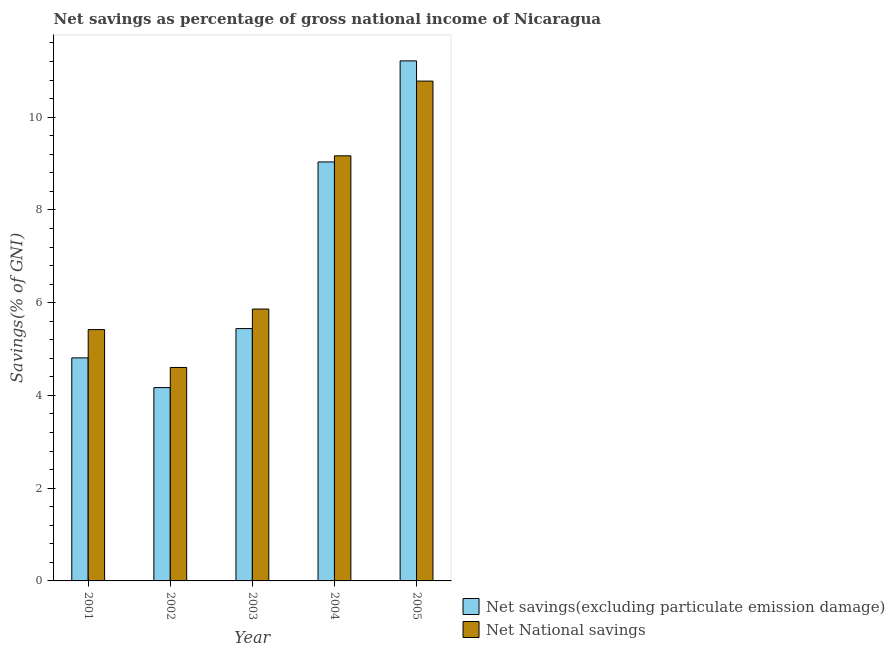Are the number of bars per tick equal to the number of legend labels?
Your answer should be very brief. Yes. Are the number of bars on each tick of the X-axis equal?
Your response must be concise. Yes. How many bars are there on the 5th tick from the right?
Your response must be concise. 2. What is the label of the 5th group of bars from the left?
Your answer should be compact. 2005. In how many cases, is the number of bars for a given year not equal to the number of legend labels?
Make the answer very short. 0. What is the net national savings in 2002?
Ensure brevity in your answer.  4.6. Across all years, what is the maximum net savings(excluding particulate emission damage)?
Provide a succinct answer. 11.21. Across all years, what is the minimum net savings(excluding particulate emission damage)?
Provide a succinct answer. 4.17. In which year was the net savings(excluding particulate emission damage) minimum?
Your response must be concise. 2002. What is the total net national savings in the graph?
Your answer should be compact. 35.83. What is the difference between the net national savings in 2001 and that in 2002?
Offer a very short reply. 0.82. What is the difference between the net national savings in 2005 and the net savings(excluding particulate emission damage) in 2004?
Keep it short and to the point. 1.61. What is the average net national savings per year?
Provide a short and direct response. 7.17. What is the ratio of the net national savings in 2001 to that in 2004?
Your answer should be compact. 0.59. Is the net savings(excluding particulate emission damage) in 2001 less than that in 2002?
Your answer should be compact. No. Is the difference between the net savings(excluding particulate emission damage) in 2002 and 2004 greater than the difference between the net national savings in 2002 and 2004?
Give a very brief answer. No. What is the difference between the highest and the second highest net savings(excluding particulate emission damage)?
Your answer should be compact. 2.18. What is the difference between the highest and the lowest net national savings?
Make the answer very short. 6.18. What does the 1st bar from the left in 2003 represents?
Your response must be concise. Net savings(excluding particulate emission damage). What does the 1st bar from the right in 2004 represents?
Your response must be concise. Net National savings. Are all the bars in the graph horizontal?
Give a very brief answer. No. How many years are there in the graph?
Offer a very short reply. 5. What is the difference between two consecutive major ticks on the Y-axis?
Keep it short and to the point. 2. Does the graph contain any zero values?
Give a very brief answer. No. Where does the legend appear in the graph?
Your answer should be very brief. Bottom right. What is the title of the graph?
Your response must be concise. Net savings as percentage of gross national income of Nicaragua. What is the label or title of the X-axis?
Provide a short and direct response. Year. What is the label or title of the Y-axis?
Your answer should be very brief. Savings(% of GNI). What is the Savings(% of GNI) in Net savings(excluding particulate emission damage) in 2001?
Your answer should be very brief. 4.81. What is the Savings(% of GNI) in Net National savings in 2001?
Your answer should be compact. 5.42. What is the Savings(% of GNI) of Net savings(excluding particulate emission damage) in 2002?
Ensure brevity in your answer.  4.17. What is the Savings(% of GNI) of Net National savings in 2002?
Provide a short and direct response. 4.6. What is the Savings(% of GNI) of Net savings(excluding particulate emission damage) in 2003?
Your response must be concise. 5.44. What is the Savings(% of GNI) of Net National savings in 2003?
Keep it short and to the point. 5.86. What is the Savings(% of GNI) of Net savings(excluding particulate emission damage) in 2004?
Your answer should be very brief. 9.04. What is the Savings(% of GNI) of Net National savings in 2004?
Make the answer very short. 9.17. What is the Savings(% of GNI) in Net savings(excluding particulate emission damage) in 2005?
Offer a terse response. 11.21. What is the Savings(% of GNI) of Net National savings in 2005?
Ensure brevity in your answer.  10.78. Across all years, what is the maximum Savings(% of GNI) of Net savings(excluding particulate emission damage)?
Provide a short and direct response. 11.21. Across all years, what is the maximum Savings(% of GNI) of Net National savings?
Your answer should be very brief. 10.78. Across all years, what is the minimum Savings(% of GNI) in Net savings(excluding particulate emission damage)?
Your response must be concise. 4.17. Across all years, what is the minimum Savings(% of GNI) in Net National savings?
Offer a very short reply. 4.6. What is the total Savings(% of GNI) of Net savings(excluding particulate emission damage) in the graph?
Give a very brief answer. 34.67. What is the total Savings(% of GNI) in Net National savings in the graph?
Your answer should be compact. 35.83. What is the difference between the Savings(% of GNI) in Net savings(excluding particulate emission damage) in 2001 and that in 2002?
Offer a terse response. 0.64. What is the difference between the Savings(% of GNI) in Net National savings in 2001 and that in 2002?
Your answer should be compact. 0.82. What is the difference between the Savings(% of GNI) of Net savings(excluding particulate emission damage) in 2001 and that in 2003?
Your answer should be very brief. -0.63. What is the difference between the Savings(% of GNI) in Net National savings in 2001 and that in 2003?
Keep it short and to the point. -0.44. What is the difference between the Savings(% of GNI) in Net savings(excluding particulate emission damage) in 2001 and that in 2004?
Your response must be concise. -4.23. What is the difference between the Savings(% of GNI) of Net National savings in 2001 and that in 2004?
Ensure brevity in your answer.  -3.75. What is the difference between the Savings(% of GNI) in Net savings(excluding particulate emission damage) in 2001 and that in 2005?
Offer a very short reply. -6.4. What is the difference between the Savings(% of GNI) of Net National savings in 2001 and that in 2005?
Make the answer very short. -5.36. What is the difference between the Savings(% of GNI) in Net savings(excluding particulate emission damage) in 2002 and that in 2003?
Your response must be concise. -1.27. What is the difference between the Savings(% of GNI) of Net National savings in 2002 and that in 2003?
Your answer should be compact. -1.26. What is the difference between the Savings(% of GNI) in Net savings(excluding particulate emission damage) in 2002 and that in 2004?
Your answer should be compact. -4.87. What is the difference between the Savings(% of GNI) in Net National savings in 2002 and that in 2004?
Make the answer very short. -4.56. What is the difference between the Savings(% of GNI) in Net savings(excluding particulate emission damage) in 2002 and that in 2005?
Make the answer very short. -7.05. What is the difference between the Savings(% of GNI) of Net National savings in 2002 and that in 2005?
Offer a very short reply. -6.17. What is the difference between the Savings(% of GNI) in Net savings(excluding particulate emission damage) in 2003 and that in 2004?
Keep it short and to the point. -3.59. What is the difference between the Savings(% of GNI) in Net National savings in 2003 and that in 2004?
Keep it short and to the point. -3.3. What is the difference between the Savings(% of GNI) of Net savings(excluding particulate emission damage) in 2003 and that in 2005?
Give a very brief answer. -5.77. What is the difference between the Savings(% of GNI) of Net National savings in 2003 and that in 2005?
Offer a very short reply. -4.92. What is the difference between the Savings(% of GNI) in Net savings(excluding particulate emission damage) in 2004 and that in 2005?
Your response must be concise. -2.18. What is the difference between the Savings(% of GNI) of Net National savings in 2004 and that in 2005?
Ensure brevity in your answer.  -1.61. What is the difference between the Savings(% of GNI) in Net savings(excluding particulate emission damage) in 2001 and the Savings(% of GNI) in Net National savings in 2002?
Give a very brief answer. 0.21. What is the difference between the Savings(% of GNI) of Net savings(excluding particulate emission damage) in 2001 and the Savings(% of GNI) of Net National savings in 2003?
Provide a succinct answer. -1.05. What is the difference between the Savings(% of GNI) of Net savings(excluding particulate emission damage) in 2001 and the Savings(% of GNI) of Net National savings in 2004?
Make the answer very short. -4.36. What is the difference between the Savings(% of GNI) of Net savings(excluding particulate emission damage) in 2001 and the Savings(% of GNI) of Net National savings in 2005?
Your answer should be compact. -5.97. What is the difference between the Savings(% of GNI) of Net savings(excluding particulate emission damage) in 2002 and the Savings(% of GNI) of Net National savings in 2003?
Your answer should be compact. -1.69. What is the difference between the Savings(% of GNI) in Net savings(excluding particulate emission damage) in 2002 and the Savings(% of GNI) in Net National savings in 2004?
Provide a short and direct response. -5. What is the difference between the Savings(% of GNI) of Net savings(excluding particulate emission damage) in 2002 and the Savings(% of GNI) of Net National savings in 2005?
Keep it short and to the point. -6.61. What is the difference between the Savings(% of GNI) in Net savings(excluding particulate emission damage) in 2003 and the Savings(% of GNI) in Net National savings in 2004?
Give a very brief answer. -3.73. What is the difference between the Savings(% of GNI) in Net savings(excluding particulate emission damage) in 2003 and the Savings(% of GNI) in Net National savings in 2005?
Ensure brevity in your answer.  -5.34. What is the difference between the Savings(% of GNI) of Net savings(excluding particulate emission damage) in 2004 and the Savings(% of GNI) of Net National savings in 2005?
Give a very brief answer. -1.74. What is the average Savings(% of GNI) in Net savings(excluding particulate emission damage) per year?
Your answer should be very brief. 6.93. What is the average Savings(% of GNI) of Net National savings per year?
Your response must be concise. 7.17. In the year 2001, what is the difference between the Savings(% of GNI) of Net savings(excluding particulate emission damage) and Savings(% of GNI) of Net National savings?
Keep it short and to the point. -0.61. In the year 2002, what is the difference between the Savings(% of GNI) in Net savings(excluding particulate emission damage) and Savings(% of GNI) in Net National savings?
Offer a terse response. -0.43. In the year 2003, what is the difference between the Savings(% of GNI) of Net savings(excluding particulate emission damage) and Savings(% of GNI) of Net National savings?
Ensure brevity in your answer.  -0.42. In the year 2004, what is the difference between the Savings(% of GNI) of Net savings(excluding particulate emission damage) and Savings(% of GNI) of Net National savings?
Make the answer very short. -0.13. In the year 2005, what is the difference between the Savings(% of GNI) in Net savings(excluding particulate emission damage) and Savings(% of GNI) in Net National savings?
Make the answer very short. 0.44. What is the ratio of the Savings(% of GNI) of Net savings(excluding particulate emission damage) in 2001 to that in 2002?
Your response must be concise. 1.15. What is the ratio of the Savings(% of GNI) of Net National savings in 2001 to that in 2002?
Give a very brief answer. 1.18. What is the ratio of the Savings(% of GNI) of Net savings(excluding particulate emission damage) in 2001 to that in 2003?
Your answer should be very brief. 0.88. What is the ratio of the Savings(% of GNI) in Net National savings in 2001 to that in 2003?
Your answer should be very brief. 0.92. What is the ratio of the Savings(% of GNI) in Net savings(excluding particulate emission damage) in 2001 to that in 2004?
Ensure brevity in your answer.  0.53. What is the ratio of the Savings(% of GNI) in Net National savings in 2001 to that in 2004?
Ensure brevity in your answer.  0.59. What is the ratio of the Savings(% of GNI) of Net savings(excluding particulate emission damage) in 2001 to that in 2005?
Give a very brief answer. 0.43. What is the ratio of the Savings(% of GNI) of Net National savings in 2001 to that in 2005?
Give a very brief answer. 0.5. What is the ratio of the Savings(% of GNI) in Net savings(excluding particulate emission damage) in 2002 to that in 2003?
Your answer should be compact. 0.77. What is the ratio of the Savings(% of GNI) in Net National savings in 2002 to that in 2003?
Provide a succinct answer. 0.79. What is the ratio of the Savings(% of GNI) in Net savings(excluding particulate emission damage) in 2002 to that in 2004?
Give a very brief answer. 0.46. What is the ratio of the Savings(% of GNI) in Net National savings in 2002 to that in 2004?
Ensure brevity in your answer.  0.5. What is the ratio of the Savings(% of GNI) of Net savings(excluding particulate emission damage) in 2002 to that in 2005?
Give a very brief answer. 0.37. What is the ratio of the Savings(% of GNI) in Net National savings in 2002 to that in 2005?
Provide a short and direct response. 0.43. What is the ratio of the Savings(% of GNI) of Net savings(excluding particulate emission damage) in 2003 to that in 2004?
Your answer should be very brief. 0.6. What is the ratio of the Savings(% of GNI) of Net National savings in 2003 to that in 2004?
Your answer should be very brief. 0.64. What is the ratio of the Savings(% of GNI) of Net savings(excluding particulate emission damage) in 2003 to that in 2005?
Keep it short and to the point. 0.49. What is the ratio of the Savings(% of GNI) of Net National savings in 2003 to that in 2005?
Provide a succinct answer. 0.54. What is the ratio of the Savings(% of GNI) in Net savings(excluding particulate emission damage) in 2004 to that in 2005?
Your response must be concise. 0.81. What is the ratio of the Savings(% of GNI) in Net National savings in 2004 to that in 2005?
Your answer should be very brief. 0.85. What is the difference between the highest and the second highest Savings(% of GNI) in Net savings(excluding particulate emission damage)?
Provide a succinct answer. 2.18. What is the difference between the highest and the second highest Savings(% of GNI) of Net National savings?
Provide a short and direct response. 1.61. What is the difference between the highest and the lowest Savings(% of GNI) in Net savings(excluding particulate emission damage)?
Provide a short and direct response. 7.05. What is the difference between the highest and the lowest Savings(% of GNI) in Net National savings?
Keep it short and to the point. 6.17. 